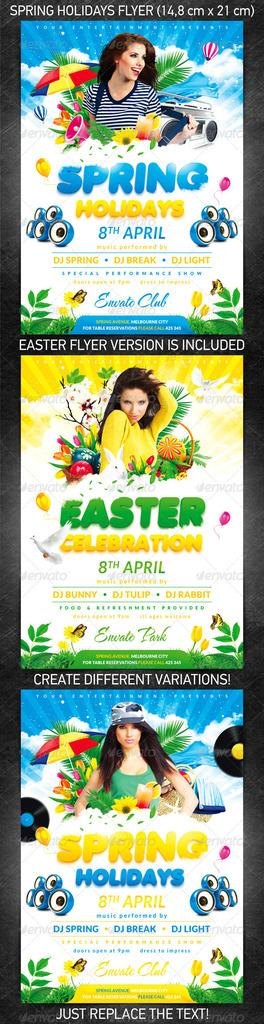<image>
Present a compact description of the photo's key features. Three posters vertically advertising Spring Holidays and Easter Celebration featuring a young brunette woman. 